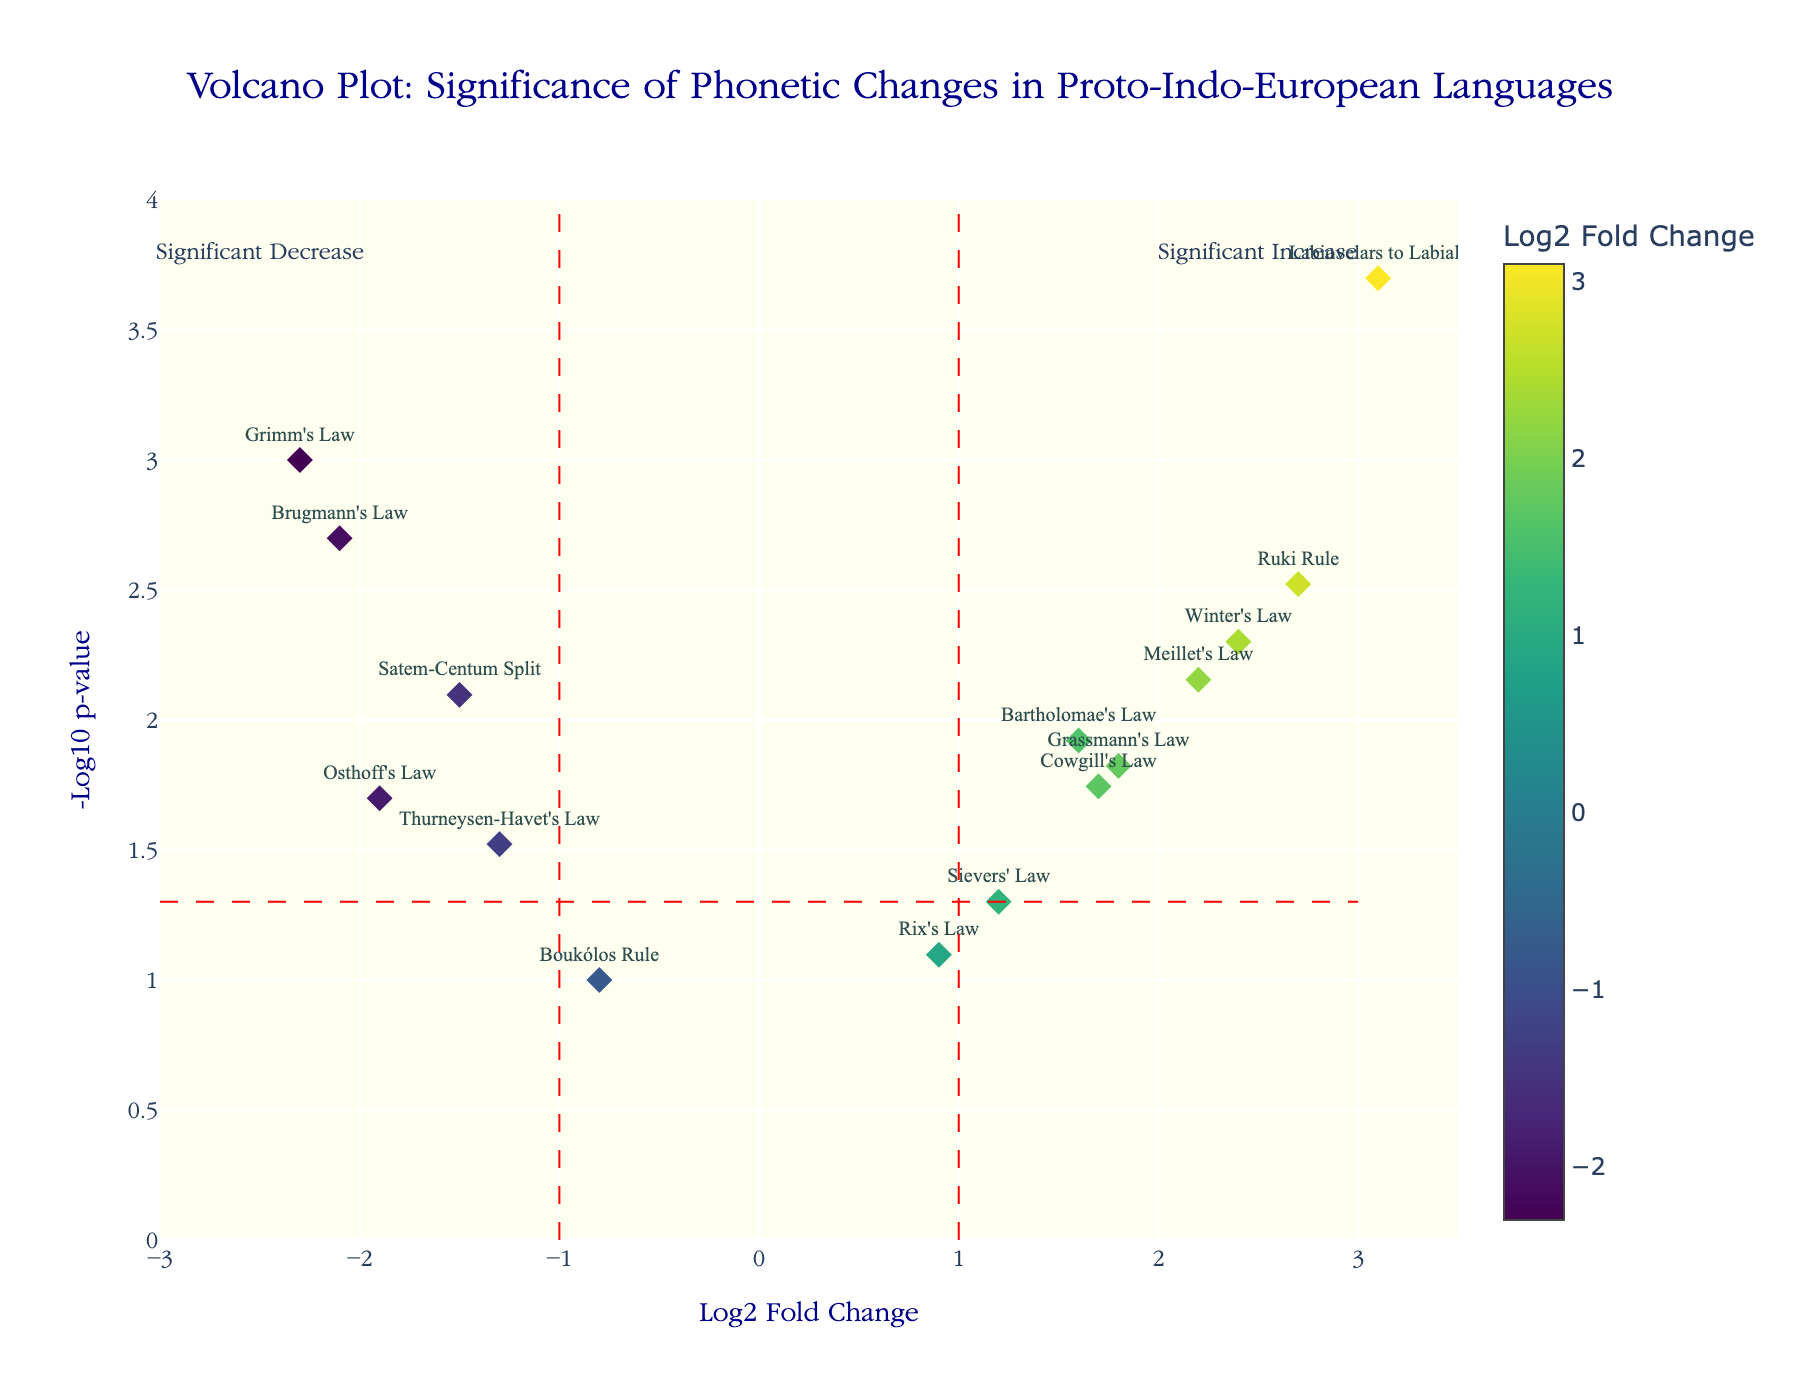What is the title of the figure? The title of the figure can be found at the top center and reads "Volcano Plot: Significance of Phonetic Changes in Proto-Indo-European Languages".
Answer: Volcano Plot: Significance of Phonetic Changes in Proto-Indo-European Languages How many phonetic changes are displayed in the plot? Each point in the plot represents a phonetic change, which can be counted. There are a total of 15 phonetic changes displayed.
Answer: 15 What does the x-axis represent in the figure? The x-axis is labeled "Log2 Fold Change", indicating that it represents the log2 transformation of fold changes in phonetic changes.
Answer: Log2 Fold Change What color indicates the highest log2 fold change? The color of the markers varies based on the log2 fold change value. The highest log2 fold change is represented by the most intense color on the Viridis color scale, which is yellow.
Answer: Yellow Which phonetic change has the lowest p-value? The p-value can be determined by the y-axis value of -Log10(p-value). The phonetic change with the highest y-axis value has the lowest p-value, which is "Labiovelars to Labials" with a p-value of 0.0002.
Answer: Labiovelars to Labials Which phonetic changes fall within the "Significant Increase" region? The "Significant Increase" region is to the right of the vertical line at log2 fold change of 1. The phonetic changes within this region are "Grassmann's Law," "Labiovelars to Labials," "Ruki Rule," "Winter's Law," "Bartholomae's Law," "Cowgill's Law," and "Meillet's Law."
Answer: Grassmann's Law, Labiovelars to Labials, Ruki Rule, Winter's Law, Bartholomae's Law, Cowgill's Law, Meillet's Law How many phonetic changes are considered statistically significant with a p-value threshold of 0.05? A p-value threshold of 0.05 corresponds to -Log10(p-value) of approximately 1.3. Count the points above this line, which are 12 in total.
Answer: 12 Which phonetic change shows a significant decrease, having the lowest log2 fold change? To identify significant decreases, look to the left of the vertical line at log2 fold change of -1. The phonetic change with the lowest log2 fold change within this region is "Grimm's Law" with a log2 fold change of -2.3.
Answer: Grimm's Law Which law has a log2 fold change closest to zero but is still statistically significant? The phonetic change closest to zero can be identified by finding the point nearest the origin on the x-axis that is above the horizontal line at -Log10(p-value) of 1.3. "Sievers' Law" has a log2 fold change of 1.2 and is statistically significant.
Answer: Sievers' Law What is the approximate -Log10(p-value) for Osthoff's Law? Find the y-axis value of the marker labeled "Osthoff's Law." It is slightly above the 1.3 threshold, indicating a -Log10(p-value) slightly greater than 1.3.
Answer: Slightly greater than 1.3 